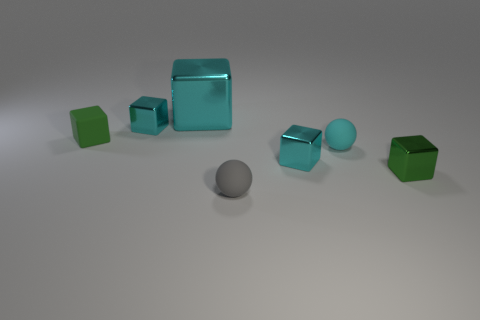There is a cyan metal cube that is in front of the green rubber block; does it have the same size as the large cyan block?
Your answer should be compact. No. There is a cyan object that is left of the cyan ball and to the right of the tiny gray matte sphere; what size is it?
Keep it short and to the point. Small. How many other things are there of the same shape as the small gray matte object?
Keep it short and to the point. 1. How many other things are there of the same material as the gray sphere?
Your answer should be very brief. 2. What size is the green metal object that is the same shape as the green rubber thing?
Offer a very short reply. Small. Do the rubber cube and the large shiny thing have the same color?
Your answer should be compact. No. There is a shiny cube that is both to the left of the cyan sphere and in front of the cyan matte object; what is its color?
Keep it short and to the point. Cyan. How many objects are small cyan rubber objects that are in front of the green matte cube or tiny green metal cubes?
Provide a succinct answer. 2. There is a big object that is the same shape as the small green matte object; what color is it?
Make the answer very short. Cyan. There is a gray object; does it have the same shape as the cyan metallic object on the right side of the large cyan object?
Your response must be concise. No. 